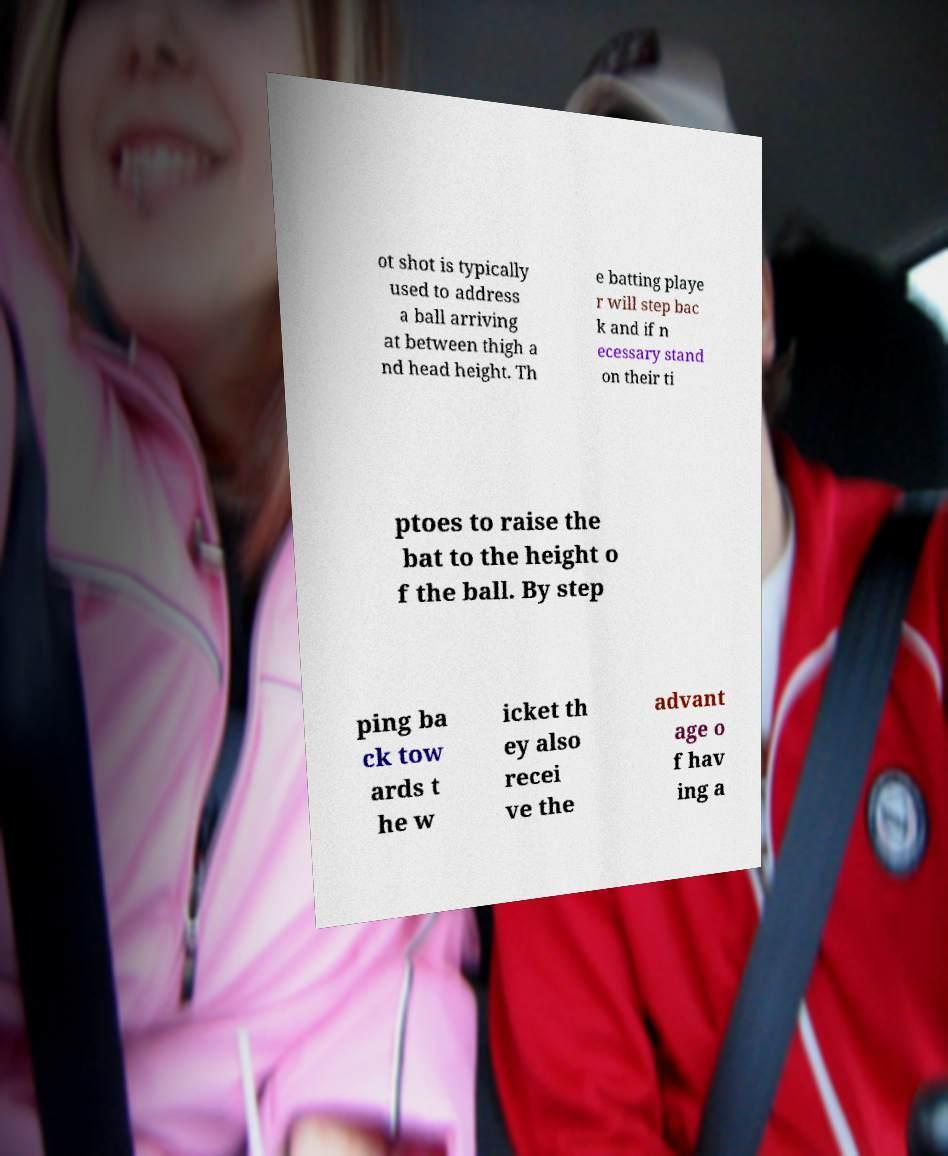Please read and relay the text visible in this image. What does it say? ot shot is typically used to address a ball arriving at between thigh a nd head height. Th e batting playe r will step bac k and if n ecessary stand on their ti ptoes to raise the bat to the height o f the ball. By step ping ba ck tow ards t he w icket th ey also recei ve the advant age o f hav ing a 